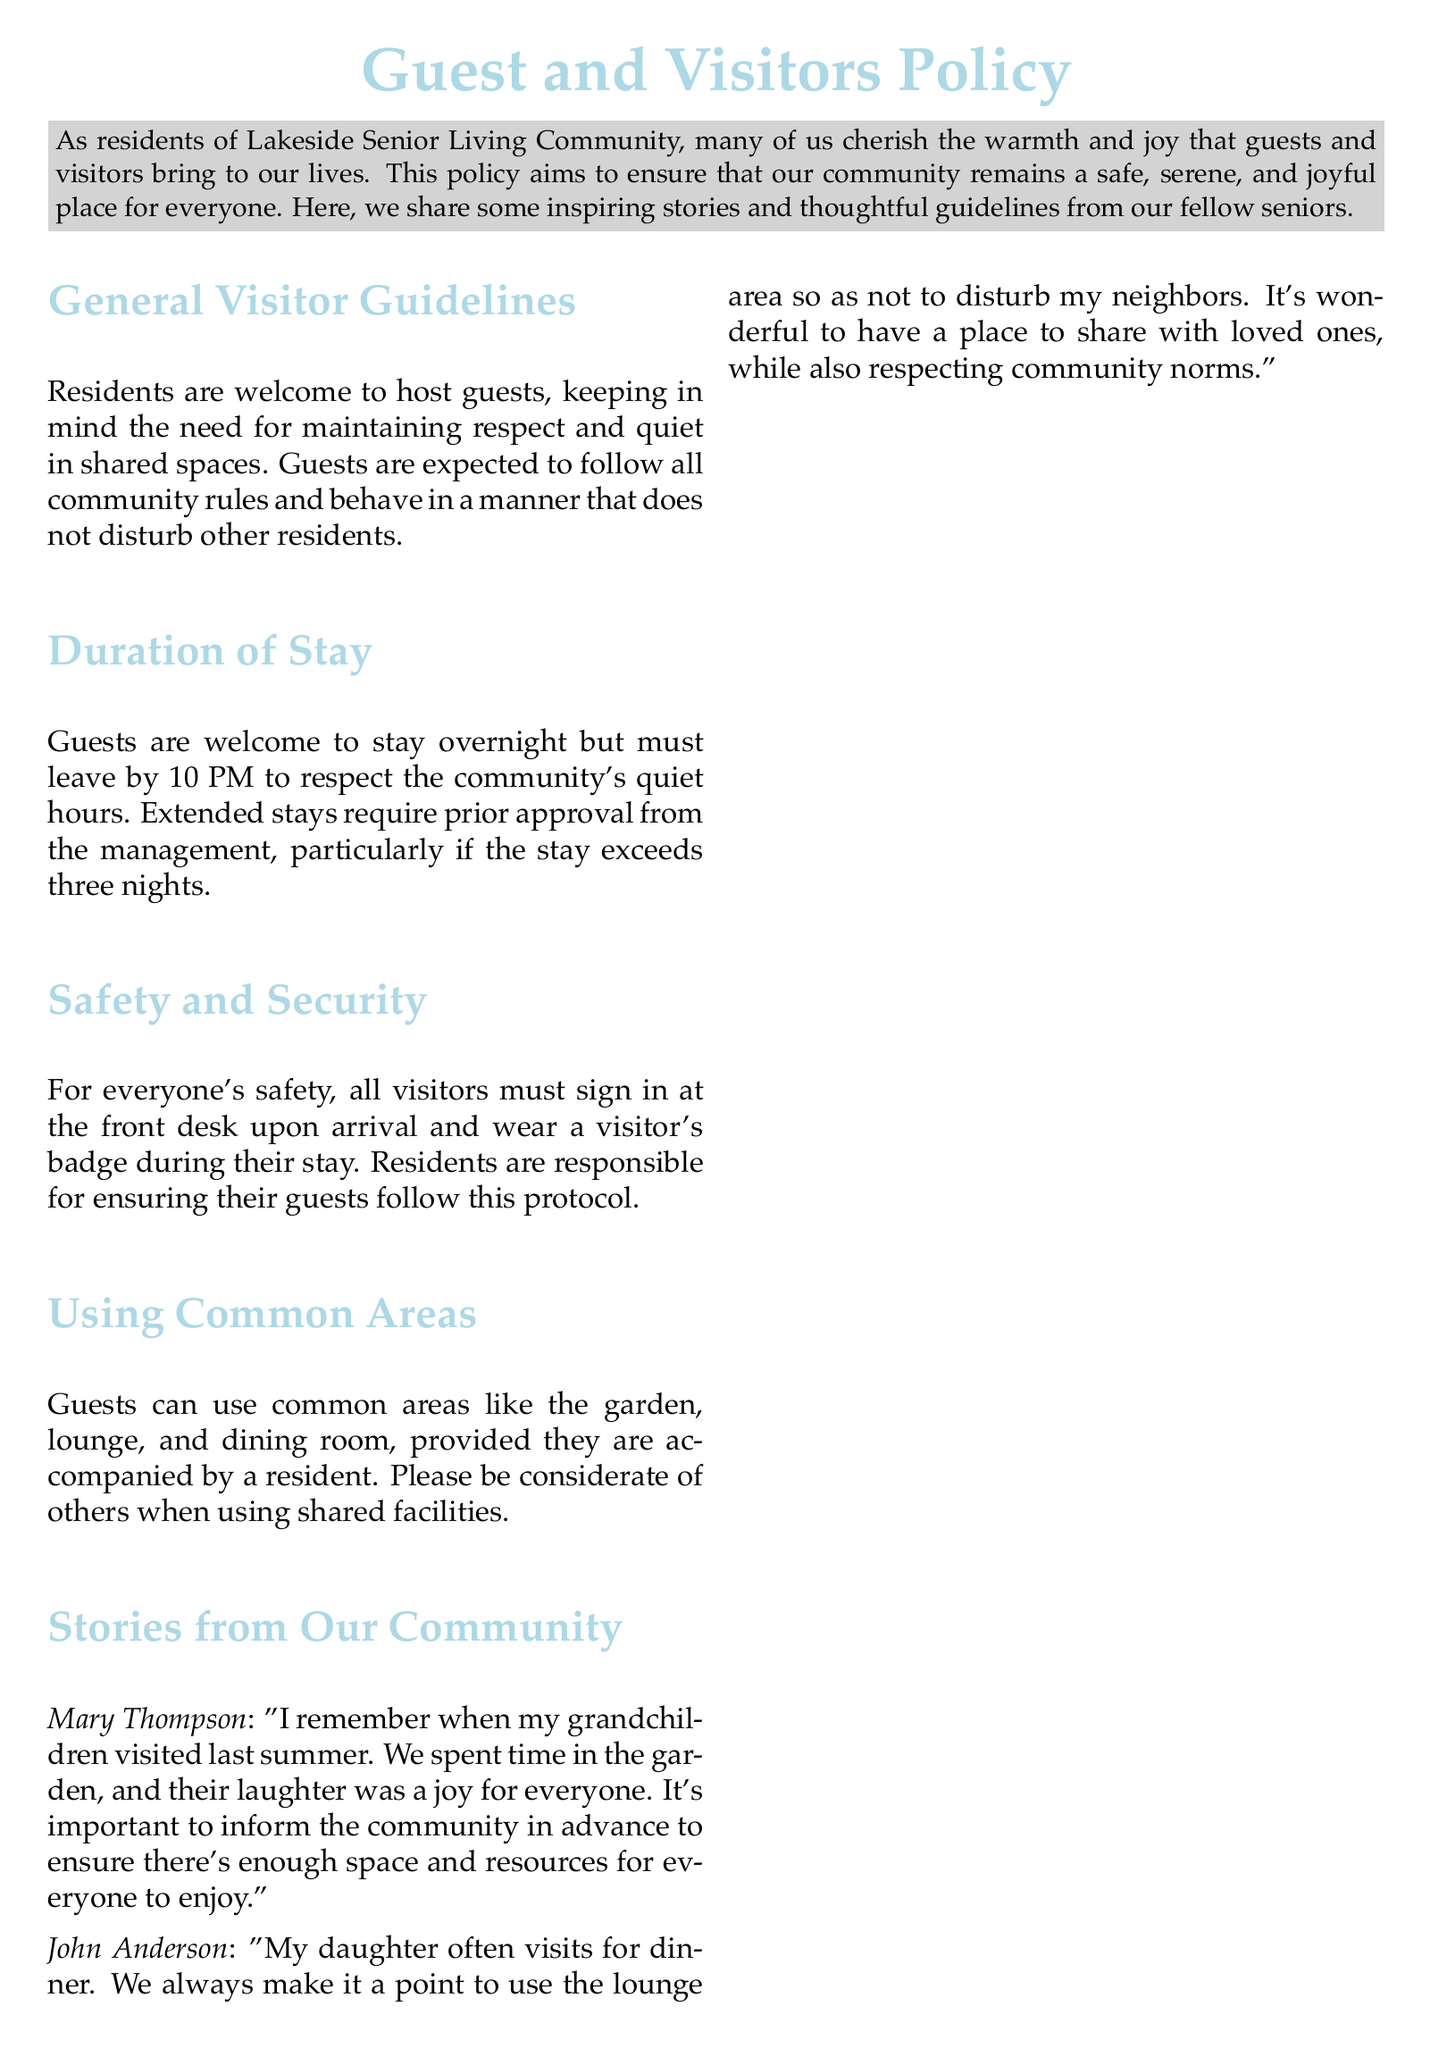what is the title of the document? The title is prominently displayed at the beginning of the document as "Guest and Visitors Policy".
Answer: Guest and Visitors Policy who is responsible for ensuring guests follow the protocol? The document states that residents are responsible for ensuring their guests follow this protocol.
Answer: Residents what time must guests leave by? The document specifies that guests must leave by 10 PM to respect quiet hours.
Answer: 10 PM how many nights can guests stay without requiring prior approval? According to the document, guests can stay for three nights without prior approval.
Answer: three nights who shared a story about grandchildren visiting? The document includes a story from Mary Thompson about her grandchildren visiting last summer.
Answer: Mary Thompson what common areas can guests use? Guests can use the garden, lounge, and dining room when accompanied by a resident.
Answer: garden, lounge, dining room what does John Anderson emphasize in his story? John Anderson emphasizes the importance of not disturbing neighbors when hosting his daughter for dinner.
Answer: not disturbing neighbors what is the main message of the conclusion section? The conclusion emphasizes maintaining a balance that respects both personal and community spaces.
Answer: balance that respects both personal and community spaces how does the document describe visitors? The document describes visitors as the flowers that make life bloom.
Answer: flowers that make it bloom 